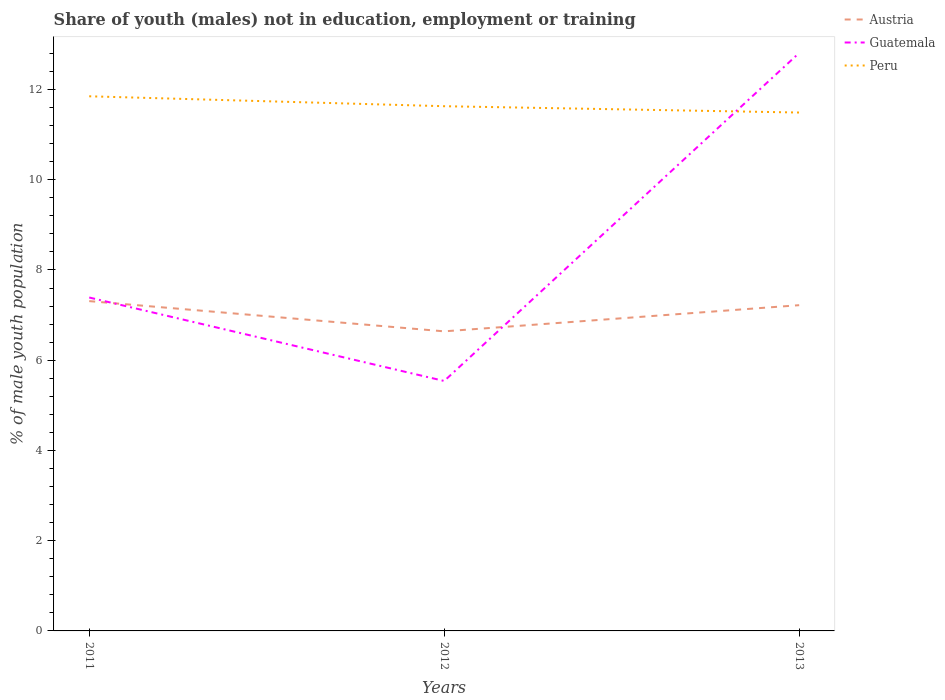Does the line corresponding to Peru intersect with the line corresponding to Austria?
Offer a very short reply. No. Across all years, what is the maximum percentage of unemployed males population in in Peru?
Your answer should be compact. 11.49. In which year was the percentage of unemployed males population in in Austria maximum?
Keep it short and to the point. 2012. What is the total percentage of unemployed males population in in Peru in the graph?
Your response must be concise. 0.36. What is the difference between the highest and the second highest percentage of unemployed males population in in Guatemala?
Offer a terse response. 7.27. Is the percentage of unemployed males population in in Guatemala strictly greater than the percentage of unemployed males population in in Peru over the years?
Ensure brevity in your answer.  No. Does the graph contain grids?
Provide a short and direct response. No. What is the title of the graph?
Offer a very short reply. Share of youth (males) not in education, employment or training. What is the label or title of the Y-axis?
Make the answer very short. % of male youth population. What is the % of male youth population in Austria in 2011?
Offer a terse response. 7.31. What is the % of male youth population in Guatemala in 2011?
Ensure brevity in your answer.  7.39. What is the % of male youth population in Peru in 2011?
Your response must be concise. 11.85. What is the % of male youth population in Austria in 2012?
Make the answer very short. 6.64. What is the % of male youth population in Guatemala in 2012?
Ensure brevity in your answer.  5.54. What is the % of male youth population of Peru in 2012?
Your answer should be very brief. 11.63. What is the % of male youth population in Austria in 2013?
Keep it short and to the point. 7.22. What is the % of male youth population in Guatemala in 2013?
Give a very brief answer. 12.81. What is the % of male youth population in Peru in 2013?
Provide a succinct answer. 11.49. Across all years, what is the maximum % of male youth population of Austria?
Ensure brevity in your answer.  7.31. Across all years, what is the maximum % of male youth population in Guatemala?
Your response must be concise. 12.81. Across all years, what is the maximum % of male youth population of Peru?
Offer a terse response. 11.85. Across all years, what is the minimum % of male youth population in Austria?
Make the answer very short. 6.64. Across all years, what is the minimum % of male youth population in Guatemala?
Give a very brief answer. 5.54. Across all years, what is the minimum % of male youth population of Peru?
Offer a terse response. 11.49. What is the total % of male youth population of Austria in the graph?
Offer a very short reply. 21.17. What is the total % of male youth population of Guatemala in the graph?
Your response must be concise. 25.74. What is the total % of male youth population in Peru in the graph?
Offer a terse response. 34.97. What is the difference between the % of male youth population in Austria in 2011 and that in 2012?
Make the answer very short. 0.67. What is the difference between the % of male youth population in Guatemala in 2011 and that in 2012?
Give a very brief answer. 1.85. What is the difference between the % of male youth population of Peru in 2011 and that in 2012?
Your response must be concise. 0.22. What is the difference between the % of male youth population in Austria in 2011 and that in 2013?
Ensure brevity in your answer.  0.09. What is the difference between the % of male youth population of Guatemala in 2011 and that in 2013?
Keep it short and to the point. -5.42. What is the difference between the % of male youth population in Peru in 2011 and that in 2013?
Keep it short and to the point. 0.36. What is the difference between the % of male youth population in Austria in 2012 and that in 2013?
Provide a short and direct response. -0.58. What is the difference between the % of male youth population of Guatemala in 2012 and that in 2013?
Give a very brief answer. -7.27. What is the difference between the % of male youth population in Peru in 2012 and that in 2013?
Offer a very short reply. 0.14. What is the difference between the % of male youth population in Austria in 2011 and the % of male youth population in Guatemala in 2012?
Offer a terse response. 1.77. What is the difference between the % of male youth population of Austria in 2011 and the % of male youth population of Peru in 2012?
Your answer should be very brief. -4.32. What is the difference between the % of male youth population in Guatemala in 2011 and the % of male youth population in Peru in 2012?
Offer a terse response. -4.24. What is the difference between the % of male youth population of Austria in 2011 and the % of male youth population of Guatemala in 2013?
Keep it short and to the point. -5.5. What is the difference between the % of male youth population in Austria in 2011 and the % of male youth population in Peru in 2013?
Provide a succinct answer. -4.18. What is the difference between the % of male youth population of Austria in 2012 and the % of male youth population of Guatemala in 2013?
Offer a very short reply. -6.17. What is the difference between the % of male youth population of Austria in 2012 and the % of male youth population of Peru in 2013?
Make the answer very short. -4.85. What is the difference between the % of male youth population of Guatemala in 2012 and the % of male youth population of Peru in 2013?
Your response must be concise. -5.95. What is the average % of male youth population in Austria per year?
Ensure brevity in your answer.  7.06. What is the average % of male youth population of Guatemala per year?
Ensure brevity in your answer.  8.58. What is the average % of male youth population of Peru per year?
Keep it short and to the point. 11.66. In the year 2011, what is the difference between the % of male youth population of Austria and % of male youth population of Guatemala?
Your answer should be compact. -0.08. In the year 2011, what is the difference between the % of male youth population of Austria and % of male youth population of Peru?
Ensure brevity in your answer.  -4.54. In the year 2011, what is the difference between the % of male youth population in Guatemala and % of male youth population in Peru?
Your answer should be very brief. -4.46. In the year 2012, what is the difference between the % of male youth population of Austria and % of male youth population of Guatemala?
Ensure brevity in your answer.  1.1. In the year 2012, what is the difference between the % of male youth population of Austria and % of male youth population of Peru?
Keep it short and to the point. -4.99. In the year 2012, what is the difference between the % of male youth population of Guatemala and % of male youth population of Peru?
Offer a very short reply. -6.09. In the year 2013, what is the difference between the % of male youth population of Austria and % of male youth population of Guatemala?
Your answer should be compact. -5.59. In the year 2013, what is the difference between the % of male youth population in Austria and % of male youth population in Peru?
Offer a terse response. -4.27. In the year 2013, what is the difference between the % of male youth population in Guatemala and % of male youth population in Peru?
Your response must be concise. 1.32. What is the ratio of the % of male youth population of Austria in 2011 to that in 2012?
Provide a succinct answer. 1.1. What is the ratio of the % of male youth population of Guatemala in 2011 to that in 2012?
Your response must be concise. 1.33. What is the ratio of the % of male youth population of Peru in 2011 to that in 2012?
Ensure brevity in your answer.  1.02. What is the ratio of the % of male youth population in Austria in 2011 to that in 2013?
Keep it short and to the point. 1.01. What is the ratio of the % of male youth population of Guatemala in 2011 to that in 2013?
Ensure brevity in your answer.  0.58. What is the ratio of the % of male youth population in Peru in 2011 to that in 2013?
Your answer should be very brief. 1.03. What is the ratio of the % of male youth population of Austria in 2012 to that in 2013?
Provide a succinct answer. 0.92. What is the ratio of the % of male youth population in Guatemala in 2012 to that in 2013?
Provide a short and direct response. 0.43. What is the ratio of the % of male youth population in Peru in 2012 to that in 2013?
Keep it short and to the point. 1.01. What is the difference between the highest and the second highest % of male youth population of Austria?
Keep it short and to the point. 0.09. What is the difference between the highest and the second highest % of male youth population of Guatemala?
Provide a succinct answer. 5.42. What is the difference between the highest and the second highest % of male youth population in Peru?
Give a very brief answer. 0.22. What is the difference between the highest and the lowest % of male youth population in Austria?
Give a very brief answer. 0.67. What is the difference between the highest and the lowest % of male youth population in Guatemala?
Your response must be concise. 7.27. What is the difference between the highest and the lowest % of male youth population in Peru?
Keep it short and to the point. 0.36. 